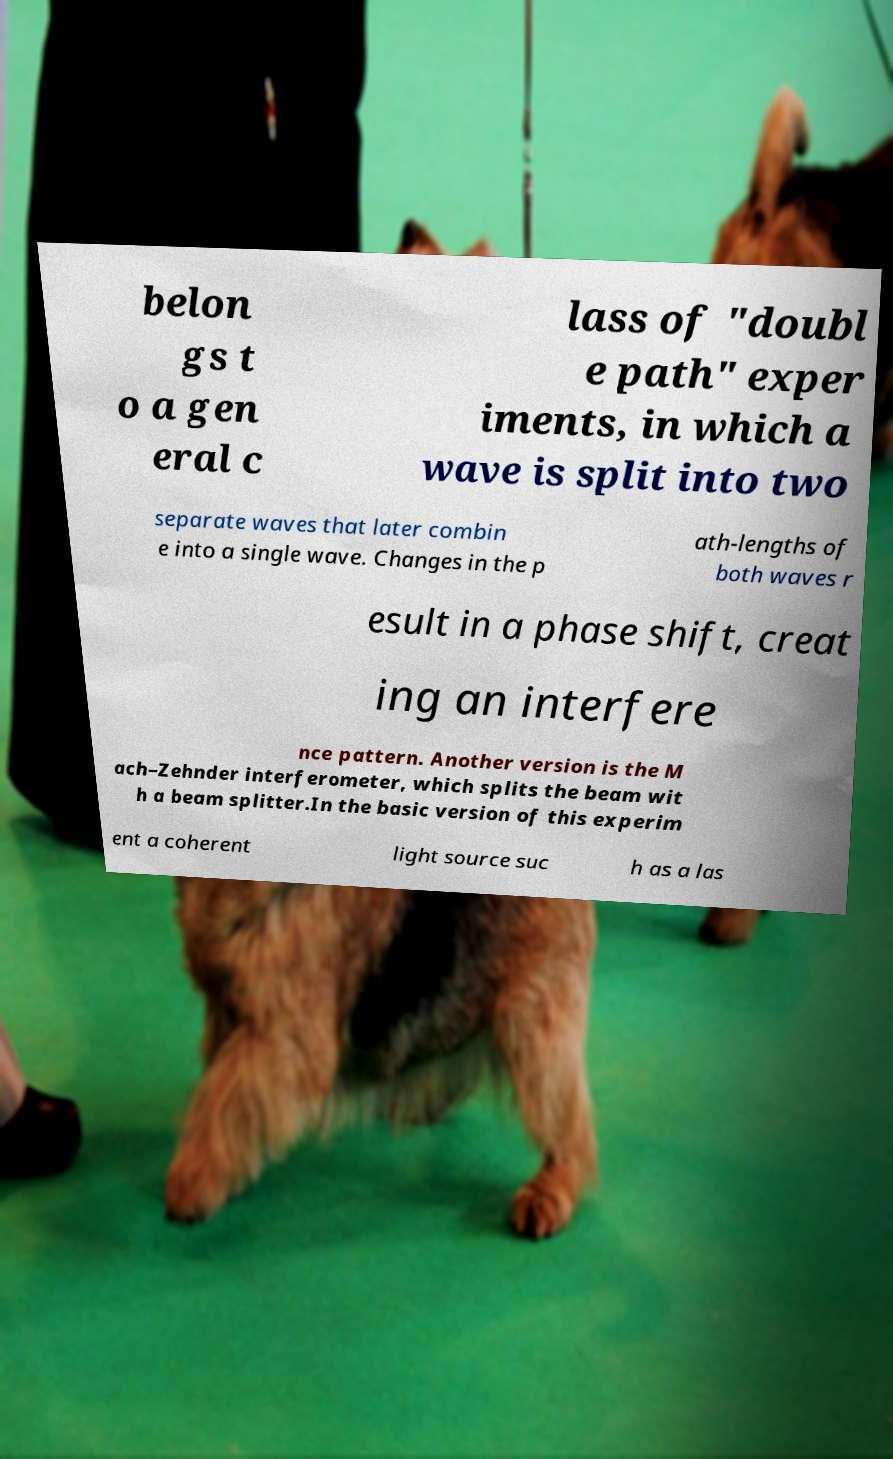Can you accurately transcribe the text from the provided image for me? belon gs t o a gen eral c lass of "doubl e path" exper iments, in which a wave is split into two separate waves that later combin e into a single wave. Changes in the p ath-lengths of both waves r esult in a phase shift, creat ing an interfere nce pattern. Another version is the M ach–Zehnder interferometer, which splits the beam wit h a beam splitter.In the basic version of this experim ent a coherent light source suc h as a las 